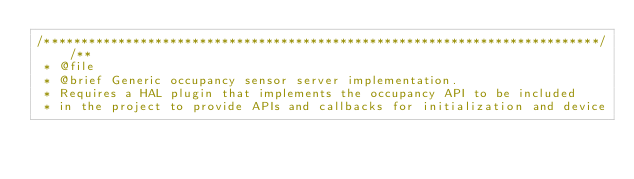<code> <loc_0><loc_0><loc_500><loc_500><_C_>/***************************************************************************//**
 * @file
 * @brief Generic occupancy sensor server implementation.
 * Requires a HAL plugin that implements the occupancy API to be included
 * in the project to provide APIs and callbacks for initialization and device</code> 